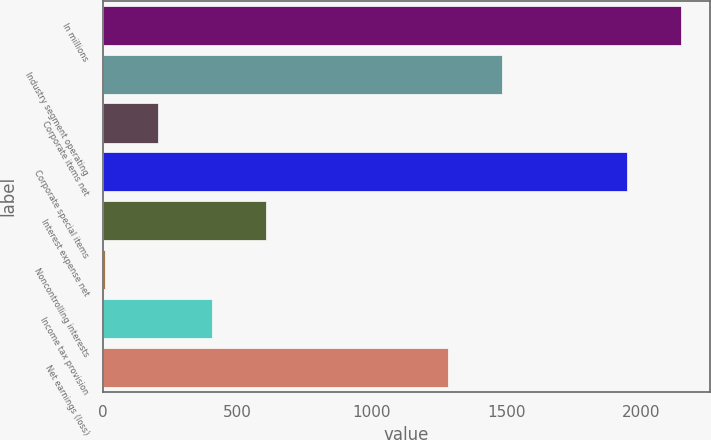Convert chart. <chart><loc_0><loc_0><loc_500><loc_500><bar_chart><fcel>In millions<fcel>Industry segment operating<fcel>Corporate items net<fcel>Corporate special items<fcel>Interest expense net<fcel>Noncontrolling interests<fcel>Income tax provision<fcel>Net earnings (loss)<nl><fcel>2149.3<fcel>1482.3<fcel>205.3<fcel>1949<fcel>605.9<fcel>5<fcel>405.6<fcel>1282<nl></chart> 